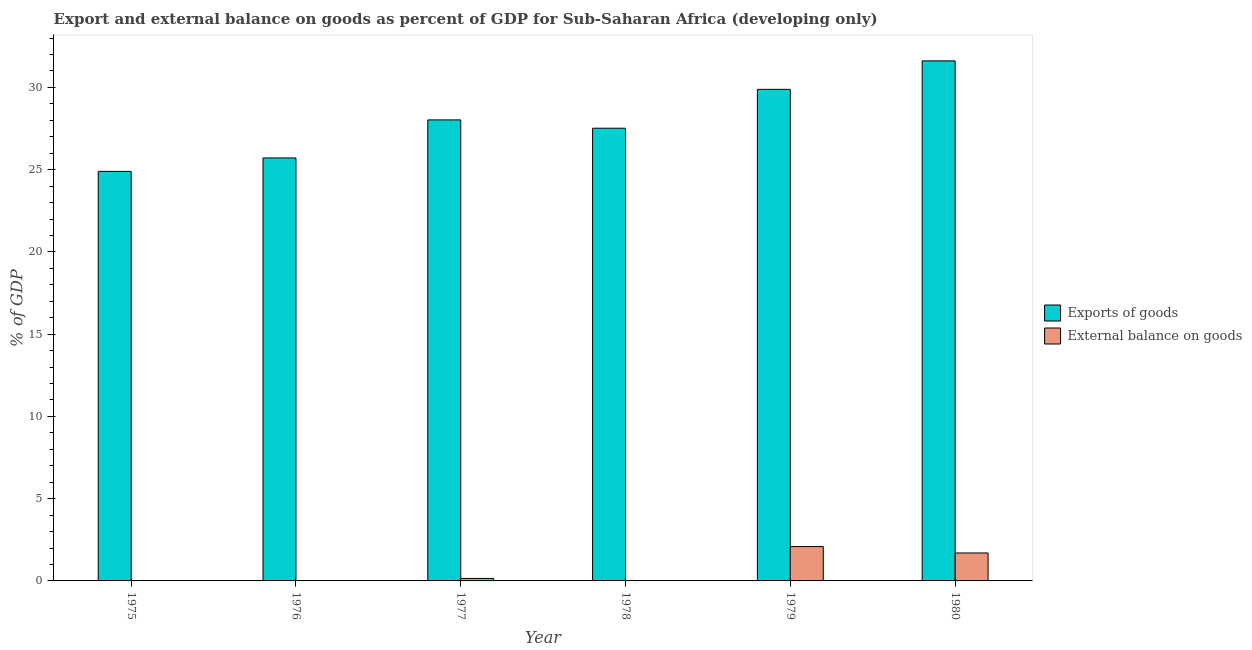How many different coloured bars are there?
Your answer should be very brief. 2. How many bars are there on the 2nd tick from the right?
Make the answer very short. 2. What is the external balance on goods as percentage of gdp in 1976?
Offer a very short reply. 0. Across all years, what is the maximum external balance on goods as percentage of gdp?
Provide a succinct answer. 2.09. Across all years, what is the minimum external balance on goods as percentage of gdp?
Give a very brief answer. 0. In which year was the export of goods as percentage of gdp maximum?
Ensure brevity in your answer.  1980. What is the total external balance on goods as percentage of gdp in the graph?
Offer a terse response. 3.94. What is the difference between the export of goods as percentage of gdp in 1976 and that in 1979?
Make the answer very short. -4.17. What is the difference between the export of goods as percentage of gdp in 1977 and the external balance on goods as percentage of gdp in 1978?
Your answer should be very brief. 0.51. What is the average external balance on goods as percentage of gdp per year?
Provide a succinct answer. 0.66. In the year 1975, what is the difference between the export of goods as percentage of gdp and external balance on goods as percentage of gdp?
Keep it short and to the point. 0. What is the ratio of the external balance on goods as percentage of gdp in 1979 to that in 1980?
Offer a terse response. 1.23. Is the difference between the export of goods as percentage of gdp in 1975 and 1976 greater than the difference between the external balance on goods as percentage of gdp in 1975 and 1976?
Your answer should be very brief. No. What is the difference between the highest and the second highest external balance on goods as percentage of gdp?
Provide a succinct answer. 0.39. What is the difference between the highest and the lowest export of goods as percentage of gdp?
Offer a terse response. 6.72. In how many years, is the export of goods as percentage of gdp greater than the average export of goods as percentage of gdp taken over all years?
Offer a terse response. 3. Is the sum of the export of goods as percentage of gdp in 1976 and 1979 greater than the maximum external balance on goods as percentage of gdp across all years?
Offer a very short reply. Yes. What is the difference between two consecutive major ticks on the Y-axis?
Offer a terse response. 5. Does the graph contain any zero values?
Make the answer very short. Yes. Does the graph contain grids?
Your answer should be compact. No. Where does the legend appear in the graph?
Provide a short and direct response. Center right. How many legend labels are there?
Ensure brevity in your answer.  2. What is the title of the graph?
Your answer should be compact. Export and external balance on goods as percent of GDP for Sub-Saharan Africa (developing only). Does "US$" appear as one of the legend labels in the graph?
Make the answer very short. No. What is the label or title of the X-axis?
Your answer should be very brief. Year. What is the label or title of the Y-axis?
Provide a short and direct response. % of GDP. What is the % of GDP in Exports of goods in 1975?
Provide a succinct answer. 24.9. What is the % of GDP of External balance on goods in 1975?
Give a very brief answer. 0. What is the % of GDP in Exports of goods in 1976?
Offer a terse response. 25.71. What is the % of GDP of Exports of goods in 1977?
Ensure brevity in your answer.  28.03. What is the % of GDP of External balance on goods in 1977?
Provide a succinct answer. 0.15. What is the % of GDP of Exports of goods in 1978?
Give a very brief answer. 27.52. What is the % of GDP of External balance on goods in 1978?
Your answer should be compact. 0. What is the % of GDP in Exports of goods in 1979?
Give a very brief answer. 29.88. What is the % of GDP of External balance on goods in 1979?
Your answer should be very brief. 2.09. What is the % of GDP of Exports of goods in 1980?
Your answer should be compact. 31.61. What is the % of GDP of External balance on goods in 1980?
Your response must be concise. 1.7. Across all years, what is the maximum % of GDP in Exports of goods?
Make the answer very short. 31.61. Across all years, what is the maximum % of GDP of External balance on goods?
Keep it short and to the point. 2.09. Across all years, what is the minimum % of GDP of Exports of goods?
Keep it short and to the point. 24.9. What is the total % of GDP of Exports of goods in the graph?
Your response must be concise. 167.66. What is the total % of GDP in External balance on goods in the graph?
Give a very brief answer. 3.94. What is the difference between the % of GDP of Exports of goods in 1975 and that in 1976?
Ensure brevity in your answer.  -0.82. What is the difference between the % of GDP of Exports of goods in 1975 and that in 1977?
Offer a terse response. -3.13. What is the difference between the % of GDP in Exports of goods in 1975 and that in 1978?
Offer a very short reply. -2.62. What is the difference between the % of GDP of Exports of goods in 1975 and that in 1979?
Offer a terse response. -4.99. What is the difference between the % of GDP in Exports of goods in 1975 and that in 1980?
Offer a terse response. -6.72. What is the difference between the % of GDP in Exports of goods in 1976 and that in 1977?
Ensure brevity in your answer.  -2.31. What is the difference between the % of GDP of Exports of goods in 1976 and that in 1978?
Provide a short and direct response. -1.81. What is the difference between the % of GDP in Exports of goods in 1976 and that in 1979?
Your response must be concise. -4.17. What is the difference between the % of GDP in Exports of goods in 1976 and that in 1980?
Offer a terse response. -5.9. What is the difference between the % of GDP of Exports of goods in 1977 and that in 1978?
Keep it short and to the point. 0.51. What is the difference between the % of GDP in Exports of goods in 1977 and that in 1979?
Give a very brief answer. -1.86. What is the difference between the % of GDP in External balance on goods in 1977 and that in 1979?
Give a very brief answer. -1.94. What is the difference between the % of GDP of Exports of goods in 1977 and that in 1980?
Your answer should be very brief. -3.59. What is the difference between the % of GDP of External balance on goods in 1977 and that in 1980?
Ensure brevity in your answer.  -1.55. What is the difference between the % of GDP of Exports of goods in 1978 and that in 1979?
Give a very brief answer. -2.36. What is the difference between the % of GDP in Exports of goods in 1978 and that in 1980?
Provide a short and direct response. -4.09. What is the difference between the % of GDP of Exports of goods in 1979 and that in 1980?
Your answer should be very brief. -1.73. What is the difference between the % of GDP in External balance on goods in 1979 and that in 1980?
Keep it short and to the point. 0.39. What is the difference between the % of GDP of Exports of goods in 1975 and the % of GDP of External balance on goods in 1977?
Make the answer very short. 24.75. What is the difference between the % of GDP of Exports of goods in 1975 and the % of GDP of External balance on goods in 1979?
Your answer should be very brief. 22.81. What is the difference between the % of GDP in Exports of goods in 1975 and the % of GDP in External balance on goods in 1980?
Make the answer very short. 23.2. What is the difference between the % of GDP of Exports of goods in 1976 and the % of GDP of External balance on goods in 1977?
Offer a terse response. 25.56. What is the difference between the % of GDP in Exports of goods in 1976 and the % of GDP in External balance on goods in 1979?
Provide a succinct answer. 23.63. What is the difference between the % of GDP of Exports of goods in 1976 and the % of GDP of External balance on goods in 1980?
Your response must be concise. 24.01. What is the difference between the % of GDP of Exports of goods in 1977 and the % of GDP of External balance on goods in 1979?
Your response must be concise. 25.94. What is the difference between the % of GDP in Exports of goods in 1977 and the % of GDP in External balance on goods in 1980?
Give a very brief answer. 26.33. What is the difference between the % of GDP in Exports of goods in 1978 and the % of GDP in External balance on goods in 1979?
Make the answer very short. 25.43. What is the difference between the % of GDP in Exports of goods in 1978 and the % of GDP in External balance on goods in 1980?
Your answer should be very brief. 25.82. What is the difference between the % of GDP of Exports of goods in 1979 and the % of GDP of External balance on goods in 1980?
Provide a short and direct response. 28.18. What is the average % of GDP of Exports of goods per year?
Your answer should be very brief. 27.94. What is the average % of GDP in External balance on goods per year?
Offer a terse response. 0.66. In the year 1977, what is the difference between the % of GDP of Exports of goods and % of GDP of External balance on goods?
Provide a short and direct response. 27.88. In the year 1979, what is the difference between the % of GDP in Exports of goods and % of GDP in External balance on goods?
Make the answer very short. 27.8. In the year 1980, what is the difference between the % of GDP of Exports of goods and % of GDP of External balance on goods?
Your response must be concise. 29.91. What is the ratio of the % of GDP of Exports of goods in 1975 to that in 1976?
Keep it short and to the point. 0.97. What is the ratio of the % of GDP in Exports of goods in 1975 to that in 1977?
Ensure brevity in your answer.  0.89. What is the ratio of the % of GDP in Exports of goods in 1975 to that in 1978?
Provide a short and direct response. 0.9. What is the ratio of the % of GDP in Exports of goods in 1975 to that in 1979?
Provide a succinct answer. 0.83. What is the ratio of the % of GDP of Exports of goods in 1975 to that in 1980?
Offer a terse response. 0.79. What is the ratio of the % of GDP of Exports of goods in 1976 to that in 1977?
Offer a terse response. 0.92. What is the ratio of the % of GDP in Exports of goods in 1976 to that in 1978?
Provide a succinct answer. 0.93. What is the ratio of the % of GDP of Exports of goods in 1976 to that in 1979?
Offer a very short reply. 0.86. What is the ratio of the % of GDP in Exports of goods in 1976 to that in 1980?
Give a very brief answer. 0.81. What is the ratio of the % of GDP in Exports of goods in 1977 to that in 1978?
Ensure brevity in your answer.  1.02. What is the ratio of the % of GDP in Exports of goods in 1977 to that in 1979?
Make the answer very short. 0.94. What is the ratio of the % of GDP in External balance on goods in 1977 to that in 1979?
Give a very brief answer. 0.07. What is the ratio of the % of GDP in Exports of goods in 1977 to that in 1980?
Make the answer very short. 0.89. What is the ratio of the % of GDP of External balance on goods in 1977 to that in 1980?
Offer a very short reply. 0.09. What is the ratio of the % of GDP in Exports of goods in 1978 to that in 1979?
Provide a short and direct response. 0.92. What is the ratio of the % of GDP in Exports of goods in 1978 to that in 1980?
Provide a succinct answer. 0.87. What is the ratio of the % of GDP in Exports of goods in 1979 to that in 1980?
Give a very brief answer. 0.95. What is the ratio of the % of GDP in External balance on goods in 1979 to that in 1980?
Make the answer very short. 1.23. What is the difference between the highest and the second highest % of GDP of Exports of goods?
Offer a very short reply. 1.73. What is the difference between the highest and the second highest % of GDP of External balance on goods?
Give a very brief answer. 0.39. What is the difference between the highest and the lowest % of GDP of Exports of goods?
Your answer should be compact. 6.72. What is the difference between the highest and the lowest % of GDP of External balance on goods?
Provide a succinct answer. 2.09. 